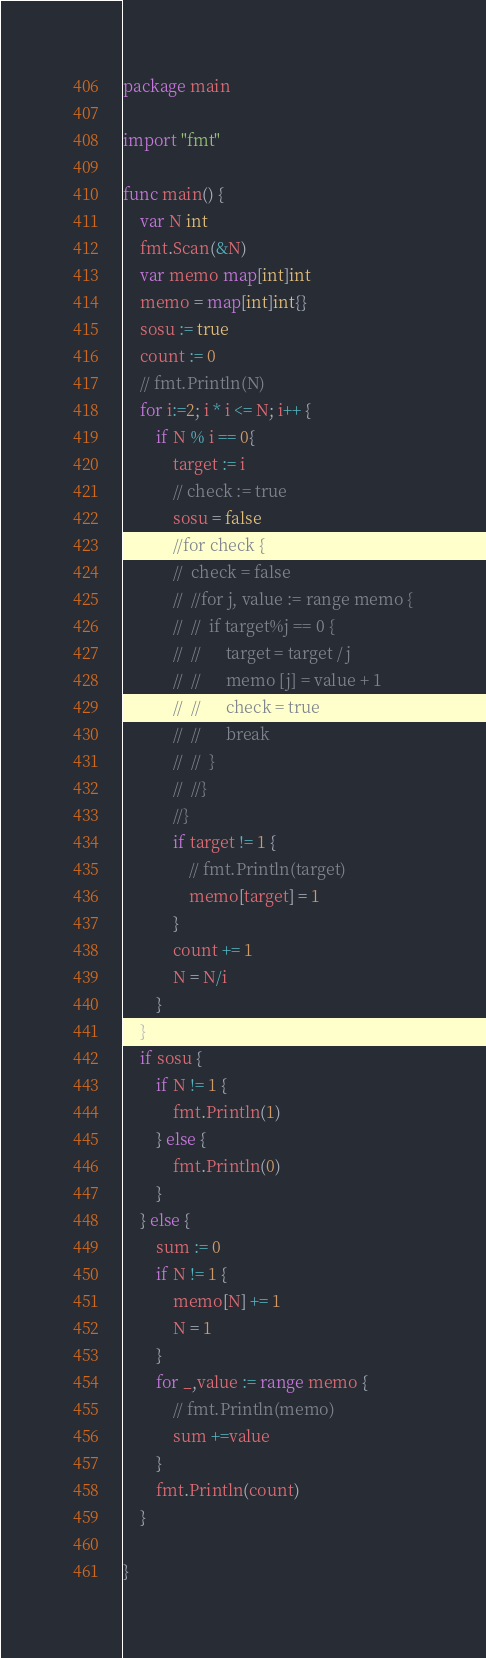<code> <loc_0><loc_0><loc_500><loc_500><_Go_>package main

import "fmt"

func main() {
	var N int
	fmt.Scan(&N)
	var memo map[int]int
	memo = map[int]int{}
	sosu := true
	count := 0
	// fmt.Println(N)
	for i:=2; i * i <= N; i++ {
		if N % i == 0{
			target := i
			// check := true
			sosu = false
			//for check {
			//	check = false
			//	//for j, value := range memo {
			//	//	if target%j == 0 {
			//	//		target = target / j
			//	//		memo [j] = value + 1
			//	//		check = true
			//	//		break
			//	//	}
			//	//}
			//}
			if target != 1 {
				// fmt.Println(target)
				memo[target] = 1
			}
			count += 1
			N = N/i
		}
	}
	if sosu {
		if N != 1 {
			fmt.Println(1)
		} else {
			fmt.Println(0)
		}
	} else {
		sum := 0
		if N != 1 {
			memo[N] += 1
			N = 1
		}
		for _,value := range memo {
			// fmt.Println(memo)
			sum +=value
		}
		fmt.Println(count)
	}

}
</code> 